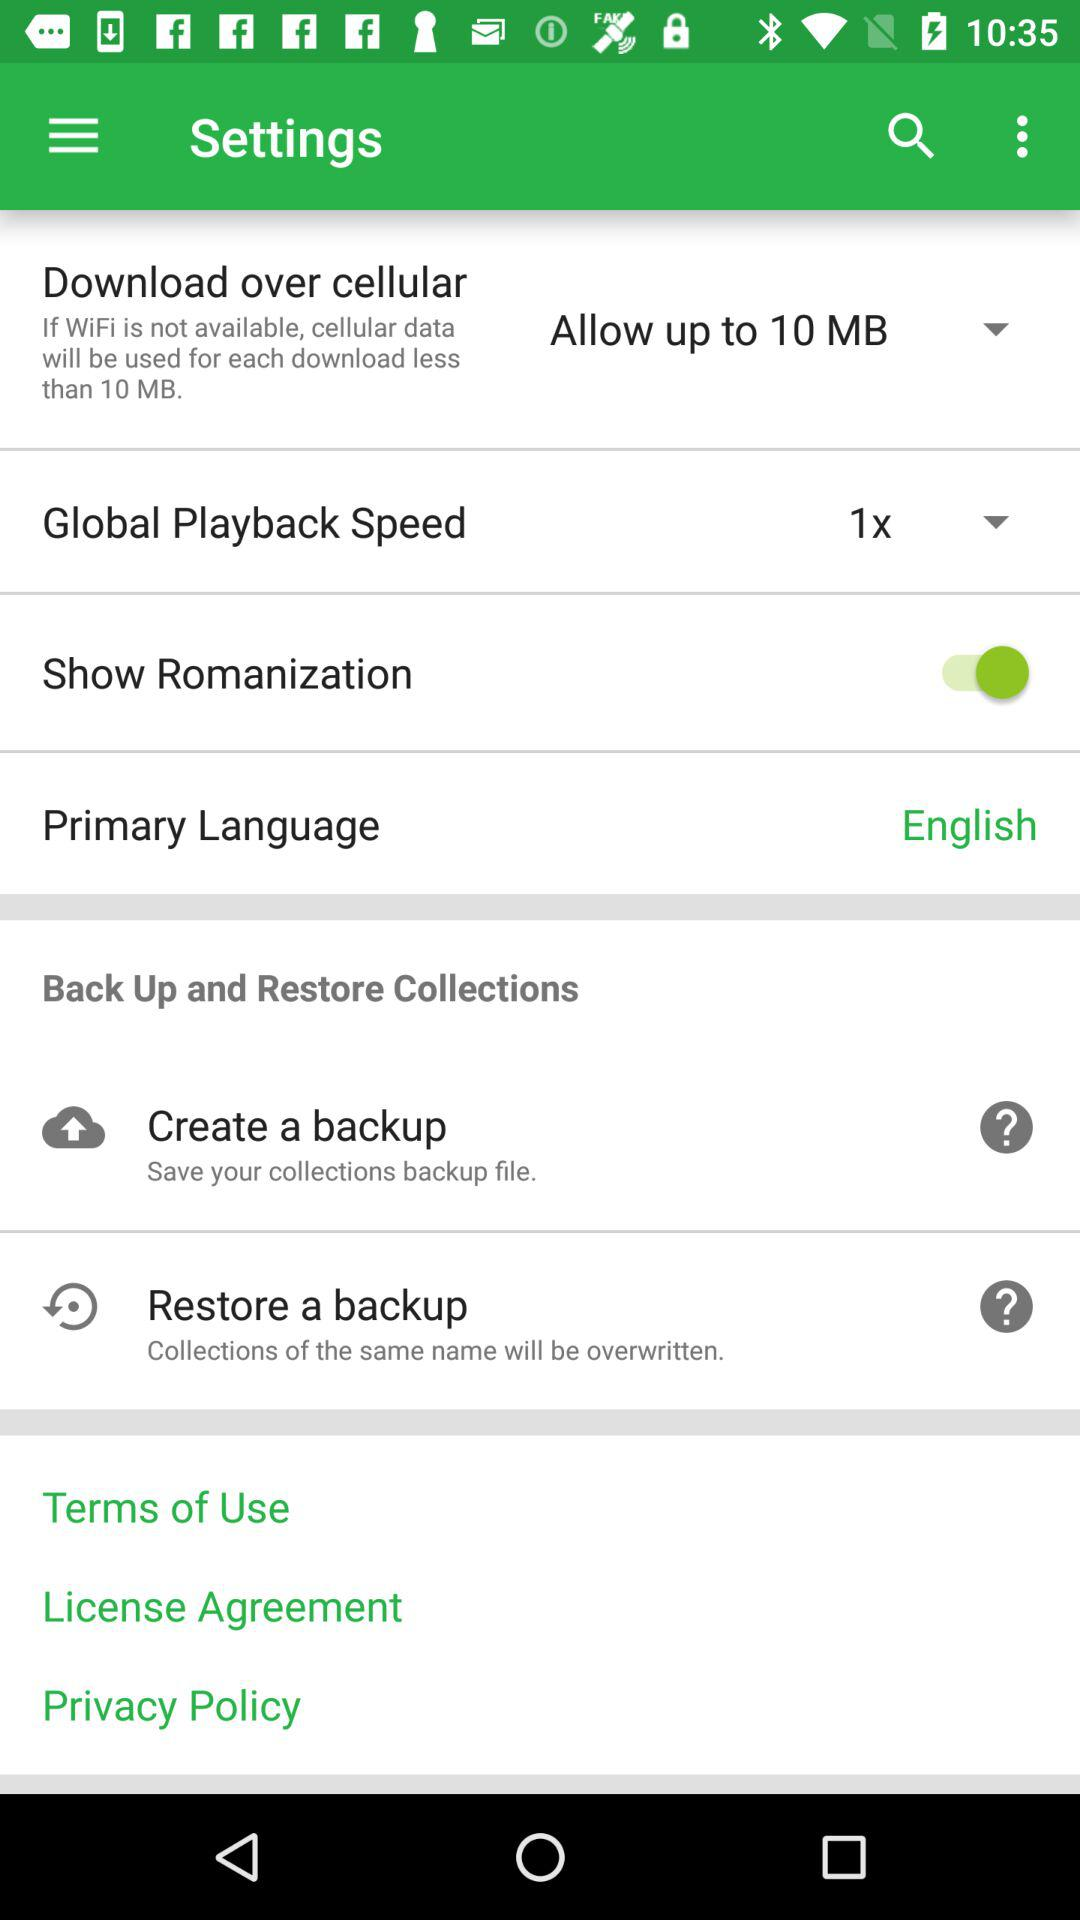What is the primary language? The primary language is English. 